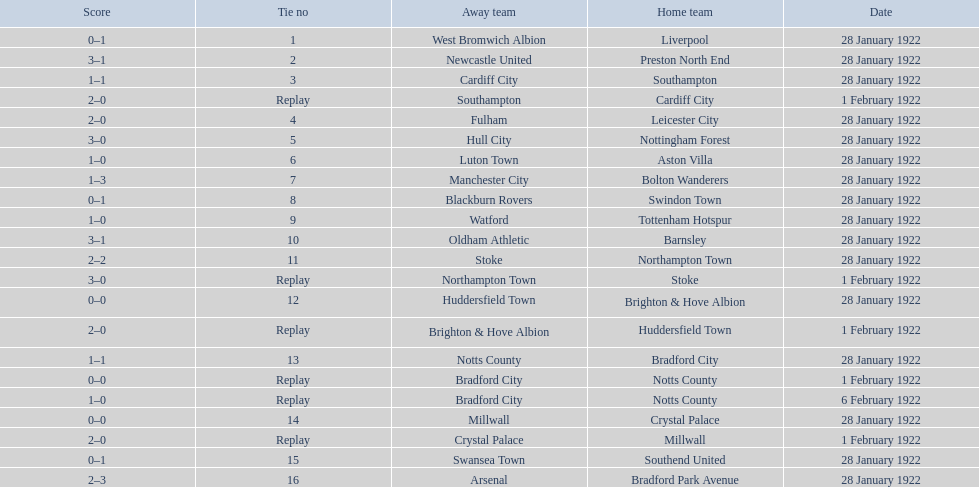What is the number of points scored on 6 february 1922? 1. 